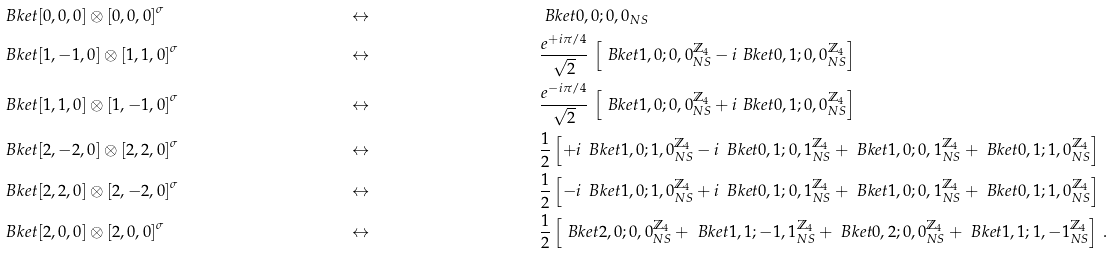Convert formula to latex. <formula><loc_0><loc_0><loc_500><loc_500>& \ B k e t { [ 0 , 0 , 0 ] \otimes [ 0 , 0 , 0 ] } ^ { \sigma } & & \leftrightarrow & & \ B k e t { 0 , 0 ; 0 , 0 } _ { N S } \\ & \ B k e t { [ 1 , - 1 , 0 ] \otimes [ 1 , 1 , 0 ] } ^ { \sigma } & & \leftrightarrow & & \frac { e ^ { + i \pi / 4 } } { \sqrt { 2 } } \, \left [ \ B k e t { 1 , 0 ; 0 , 0 } _ { N S } ^ { \mathbb { Z } _ { 4 } } - i \ B k e t { 0 , 1 ; 0 , 0 } _ { N S } ^ { \mathbb { Z } _ { 4 } } \right ] \\ & \ B k e t { [ 1 , 1 , 0 ] \otimes [ 1 , - 1 , 0 ] } ^ { \sigma } & & \leftrightarrow & & \frac { e ^ { - i \pi / 4 } } { \sqrt { 2 } } \, \left [ \ B k e t { 1 , 0 ; 0 , 0 } _ { N S } ^ { \mathbb { Z } _ { 4 } } + i \ B k e t { 0 , 1 ; 0 , 0 } _ { N S } ^ { \mathbb { Z } _ { 4 } } \right ] \\ & \ B k e t { [ 2 , - 2 , 0 ] \otimes [ 2 , 2 , 0 ] } ^ { \sigma } & & \leftrightarrow & & \frac { 1 } { 2 } \left [ + i \, \ B k e t { 1 , 0 ; 1 , 0 } _ { N S } ^ { \mathbb { Z } _ { 4 } } - i \, \ B k e t { 0 , 1 ; 0 , 1 } _ { N S } ^ { \mathbb { Z } _ { 4 } } + \ B k e t { 1 , 0 ; 0 , 1 } _ { N S } ^ { \mathbb { Z } _ { 4 } } + \ B k e t { 0 , 1 ; 1 , 0 } _ { N S } ^ { \mathbb { Z } _ { 4 } } \right ] \\ & \ B k e t { [ 2 , 2 , 0 ] \otimes [ 2 , - 2 , 0 ] } ^ { \sigma } & & \leftrightarrow & & \frac { 1 } { 2 } \left [ - i \, \ B k e t { 1 , 0 ; 1 , 0 } _ { N S } ^ { \mathbb { Z } _ { 4 } } + i \, \ B k e t { 0 , 1 ; 0 , 1 } _ { N S } ^ { \mathbb { Z } _ { 4 } } + \ B k e t { 1 , 0 ; 0 , 1 } _ { N S } ^ { \mathbb { Z } _ { 4 } } + \ B k e t { 0 , 1 ; 1 , 0 } _ { N S } ^ { \mathbb { Z } _ { 4 } } \right ] \\ & \ B k e t { [ 2 , 0 , 0 ] \otimes [ 2 , 0 , 0 ] } ^ { \sigma } & & \leftrightarrow & & \frac { 1 } { 2 } \left [ \ B k e t { 2 , 0 ; 0 , 0 } _ { N S } ^ { \mathbb { Z } _ { 4 } } + \ B k e t { 1 , 1 ; - 1 , 1 } _ { N S } ^ { \mathbb { Z } _ { 4 } } + \ B k e t { 0 , 2 ; 0 , 0 } _ { N S } ^ { \mathbb { Z } _ { 4 } } + \ B k e t { 1 , 1 ; 1 , - 1 } _ { N S } ^ { \mathbb { Z } _ { 4 } } \right ] \, .</formula> 